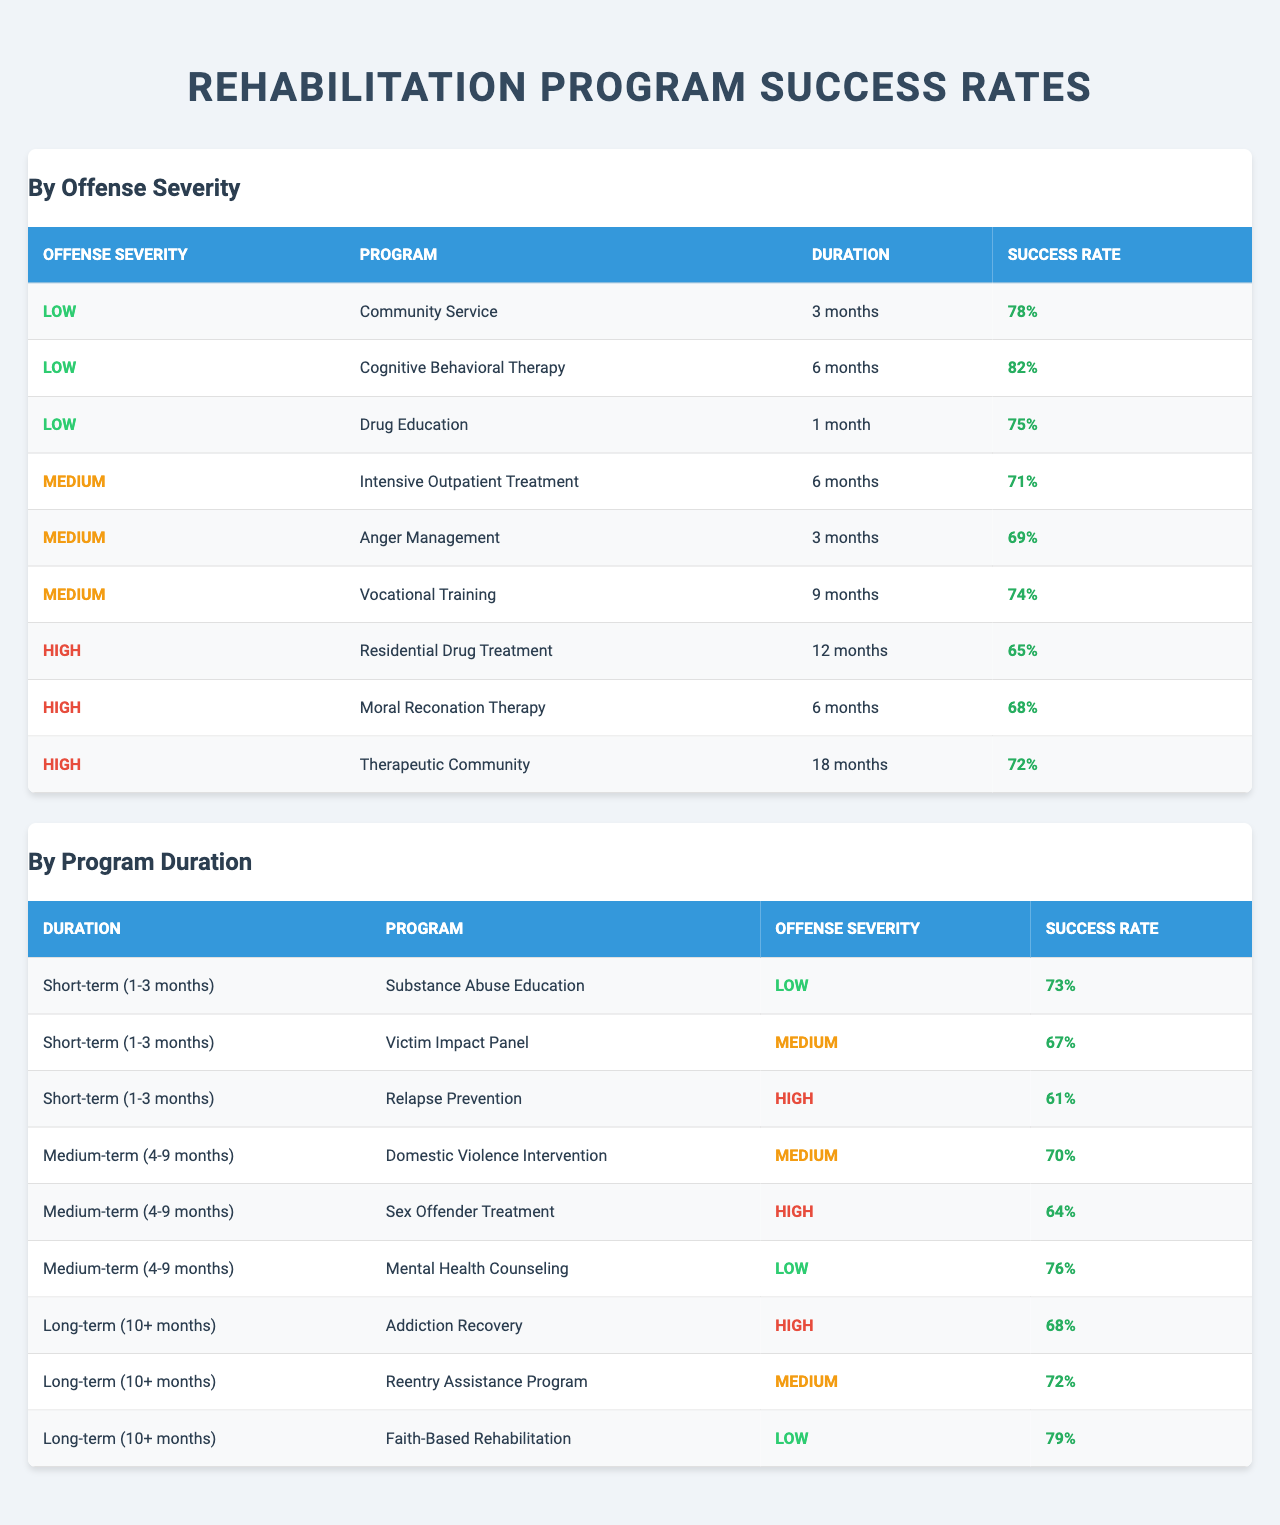What is the success rate of Cognitive Behavioral Therapy for low offense severity? The table indicates that Cognitive Behavioral Therapy has a success rate of 82% when the offense severity is categorized as low.
Answer: 82% Which rehabilitation program has the highest success rate for medium severity offenses? From the table, the program with the highest success rate for medium severity offenses is Intensive Outpatient Treatment at 71%.
Answer: 71% Is the success rate of Drug Education higher or lower than the success rate of Community Service? The success rate of Drug Education is 75%, while Community Service has a success rate of 78%. Since 75% is lower than 78%, Drug Education's success rate is lower.
Answer: Lower What is the success rate difference between Residential Drug Treatment and Faith-Based Rehabilitation? Residential Drug Treatment has a success rate of 65%, while Faith-Based Rehabilitation's success rate is 79%. The difference is calculated as 79% - 65% = 14%.
Answer: 14% Which program under long-term duration shows the best success rate for high offense severity? Among the long-term duration programs for high offense severity, Addiction Recovery has the best success rate at 68%.
Answer: 68% Count the total number of programs listed for low offense severity. The table shows three programs listed for low offense severity: Community Service, Cognitive Behavioral Therapy, and Drug Education. Thus, the total is 3.
Answer: 3 Which success rate is the median value among the success rates of all listed rehabilitation programs? Organizing all the success rates from the table gives us the values: 61%, 64%, 65%, 67%, 68%, 69%, 70%, 71%, 72%, 73%, 74%, 75%, 76%, 78%, 79%, 82%. The median of this sorted list, which has 16 values, is the average of the 8th and 9th values (71% and 72%). Thus, (71% + 72%) / 2 = 71.5%.
Answer: 71.5% What is the average success rate for all programs under short-term duration? The success rates for short-term programs are 73%, 67%, and 61%. Adding these gives 201%, and dividing by 3 results in an average of 67%.
Answer: 67% Identify the program that has the lowest success rate across all severity levels. Looking at the table, Relapse Prevention has the lowest success rate at 61% for high offense severity.
Answer: 61% Does the duration of the Therapeutic Community program fall under short-term or long-term? According to the table, the Therapeutic Community program has a duration of 18 months, which categorizes it as long-term.
Answer: Long-term Which medium-term program for low offense severity has a success rate higher than 70%? The table indicates that Mental Health Counseling, which is a medium-term program for low offense severity, has a success rate of 76%, which is indeed higher than 70%.
Answer: Yes 